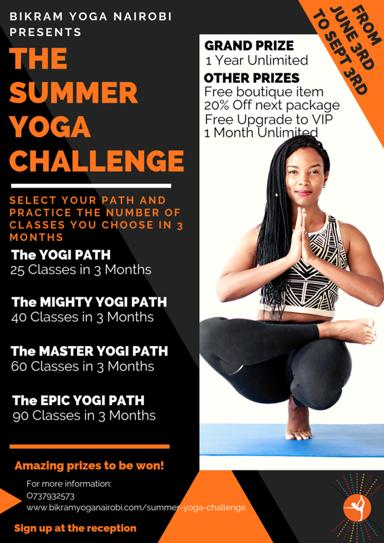What might be the benefits of choosing the Epic Yogi Path? Choosing the Epic Yogi Path in the Summer Yoga Challenge offers profound benefits, including accelerated physical and mental growth, enhanced endurance, and a deeper spiritual connection. This intensive path is designed for those committed to transforming their yoga practice and achieving remarkable wellness goals within a concentrated timeframe. 